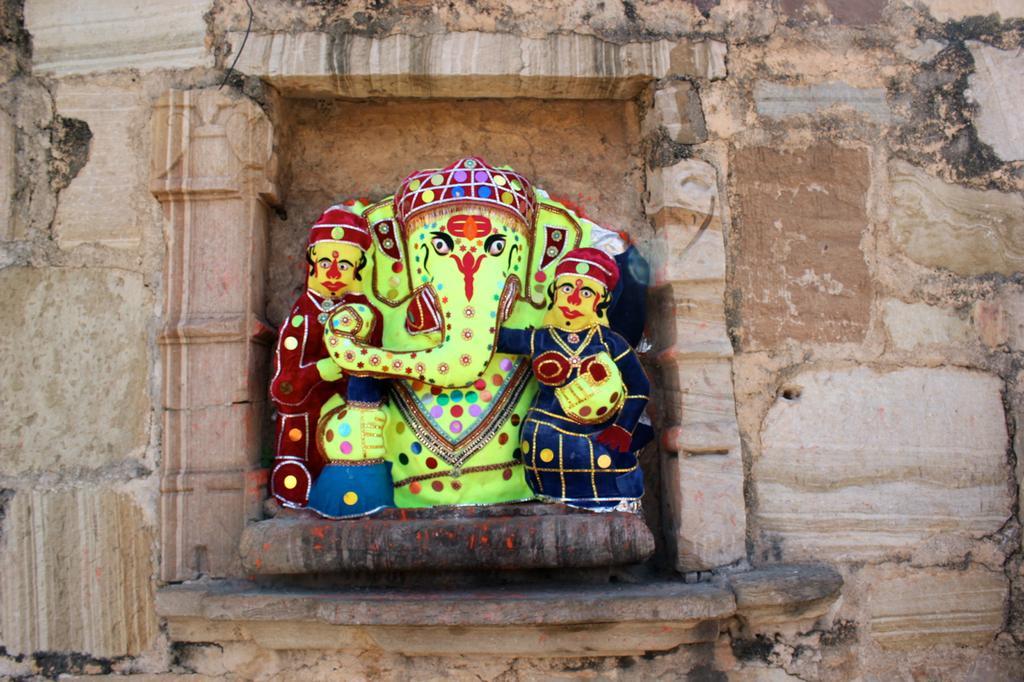Can you describe this image briefly? In the picture we can see a historical wall with a god Ganesha sculpture to it and beside we can see two person sculptures to it. 